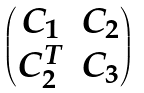Convert formula to latex. <formula><loc_0><loc_0><loc_500><loc_500>\begin{pmatrix} C _ { 1 } & C _ { 2 } \\ C _ { 2 } ^ { T } & C _ { 3 } \end{pmatrix}</formula> 